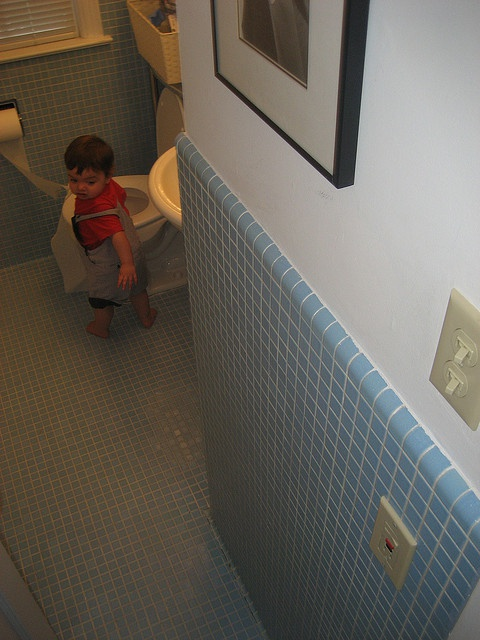Describe the objects in this image and their specific colors. I can see people in maroon and black tones, toilet in maroon, olive, and orange tones, and sink in maroon, orange, and tan tones in this image. 